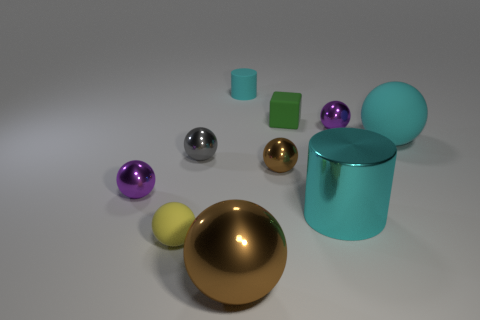Subtract all purple metallic spheres. How many spheres are left? 5 Subtract all brown spheres. How many spheres are left? 5 Subtract all blocks. How many objects are left? 9 Subtract 1 cubes. How many cubes are left? 0 Subtract all red cylinders. Subtract all green spheres. How many cylinders are left? 2 Subtract all cyan spheres. How many blue cylinders are left? 0 Subtract all yellow cubes. Subtract all large cyan cylinders. How many objects are left? 9 Add 7 big cyan rubber balls. How many big cyan rubber balls are left? 8 Add 8 tiny yellow rubber balls. How many tiny yellow rubber balls exist? 9 Subtract 1 green cubes. How many objects are left? 9 